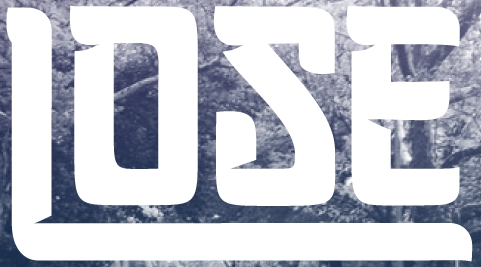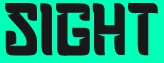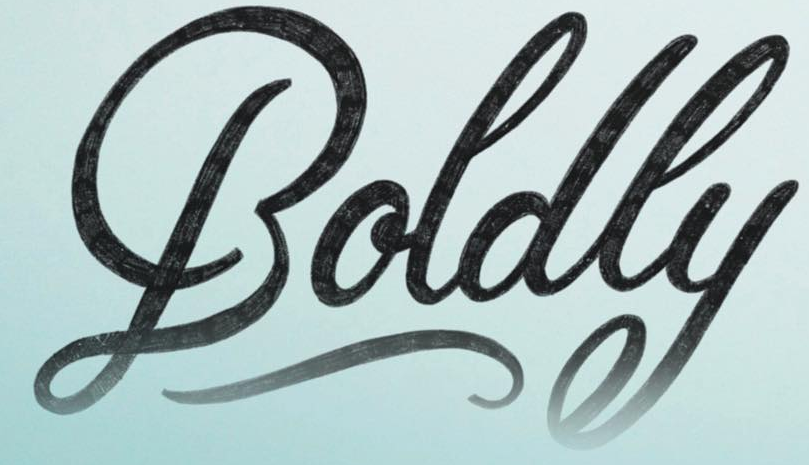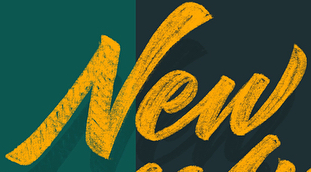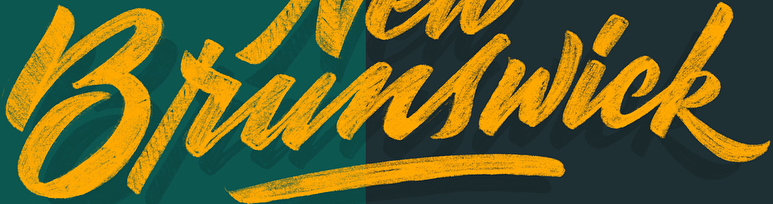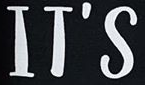Identify the words shown in these images in order, separated by a semicolon. LOSE; SIGHT; Boldly; New; Brunswick; IT'S 